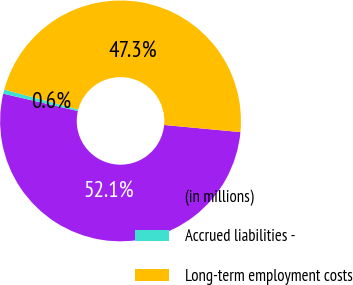Convert chart to OTSL. <chart><loc_0><loc_0><loc_500><loc_500><pie_chart><fcel>(in millions)<fcel>Accrued liabilities -<fcel>Long-term employment costs<nl><fcel>52.15%<fcel>0.56%<fcel>47.29%<nl></chart> 